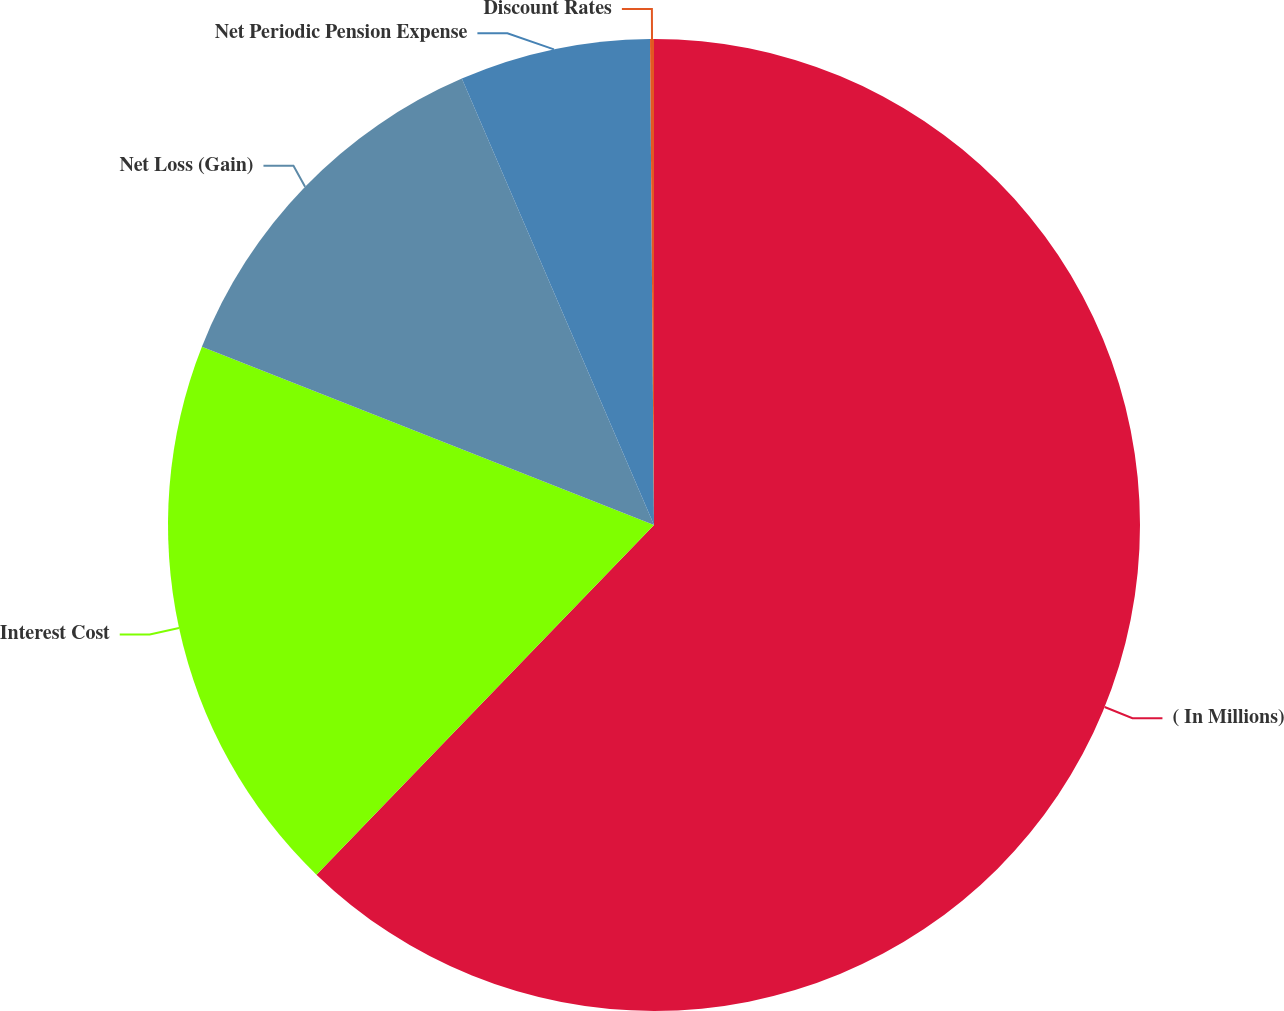Convert chart. <chart><loc_0><loc_0><loc_500><loc_500><pie_chart><fcel>( In Millions)<fcel>Interest Cost<fcel>Net Loss (Gain)<fcel>Net Periodic Pension Expense<fcel>Discount Rates<nl><fcel>62.22%<fcel>18.76%<fcel>12.55%<fcel>6.34%<fcel>0.13%<nl></chart> 